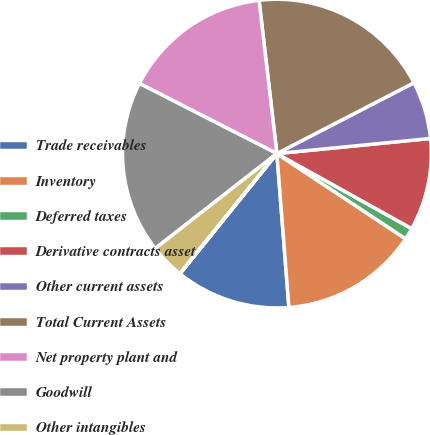<chart> <loc_0><loc_0><loc_500><loc_500><pie_chart><fcel>Trade receivables<fcel>Inventory<fcel>Deferred taxes<fcel>Derivative contracts asset<fcel>Other current assets<fcel>Total Current Assets<fcel>Net property plant and<fcel>Goodwill<fcel>Other intangibles<fcel>Other assets<nl><fcel>12.04%<fcel>14.45%<fcel>1.23%<fcel>9.64%<fcel>6.03%<fcel>19.25%<fcel>15.65%<fcel>18.05%<fcel>3.63%<fcel>0.03%<nl></chart> 